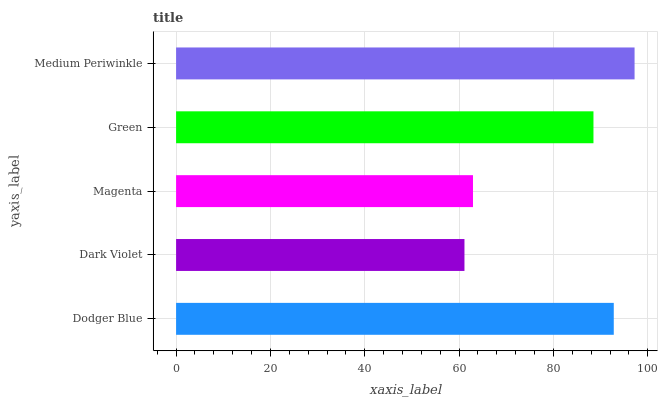Is Dark Violet the minimum?
Answer yes or no. Yes. Is Medium Periwinkle the maximum?
Answer yes or no. Yes. Is Magenta the minimum?
Answer yes or no. No. Is Magenta the maximum?
Answer yes or no. No. Is Magenta greater than Dark Violet?
Answer yes or no. Yes. Is Dark Violet less than Magenta?
Answer yes or no. Yes. Is Dark Violet greater than Magenta?
Answer yes or no. No. Is Magenta less than Dark Violet?
Answer yes or no. No. Is Green the high median?
Answer yes or no. Yes. Is Green the low median?
Answer yes or no. Yes. Is Magenta the high median?
Answer yes or no. No. Is Dark Violet the low median?
Answer yes or no. No. 